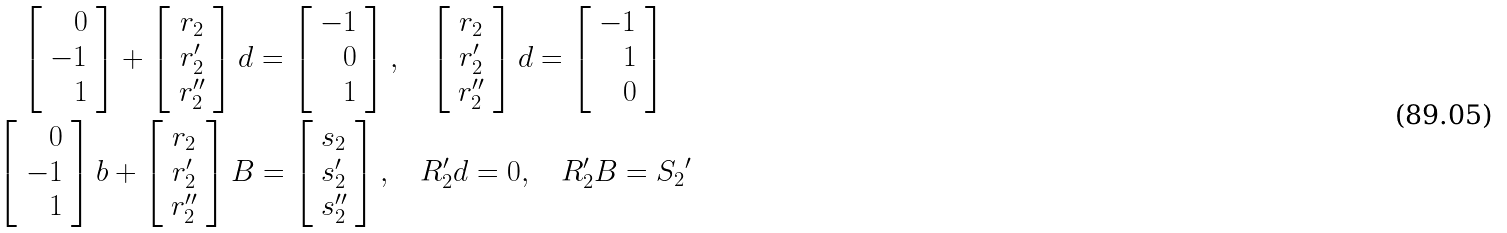<formula> <loc_0><loc_0><loc_500><loc_500>\left [ \begin{array} { r } 0 \\ - 1 \\ 1 \end{array} \right ] + \left [ \begin{array} { c } r _ { 2 } \\ r _ { 2 } ^ { \prime } \\ r _ { 2 } ^ { \prime \prime } \end{array} \right ] d = \left [ \begin{array} { r } - 1 \\ 0 \\ 1 \end{array} \right ] , \quad \left [ \begin{array} { c } r _ { 2 } \\ r _ { 2 } ^ { \prime } \\ r _ { 2 } ^ { \prime \prime } \end{array} \right ] d = \left [ \begin{array} { r } - 1 \\ 1 \\ 0 \end{array} \right ] \quad \\ \left [ \begin{array} { r } 0 \\ - 1 \\ 1 \end{array} \right ] b + \left [ \begin{array} { c } r _ { 2 } \\ r _ { 2 } ^ { \prime } \\ r _ { 2 } ^ { \prime \prime } \end{array} \right ] B = \left [ \begin{array} { c } s _ { 2 } \\ s _ { 2 } ^ { \prime } \\ s _ { 2 } ^ { \prime \prime } \end{array} \right ] , \quad R _ { 2 } ^ { \prime } d = 0 , \quad R _ { 2 } ^ { \prime } B = { S _ { 2 } } ^ { \prime }</formula> 